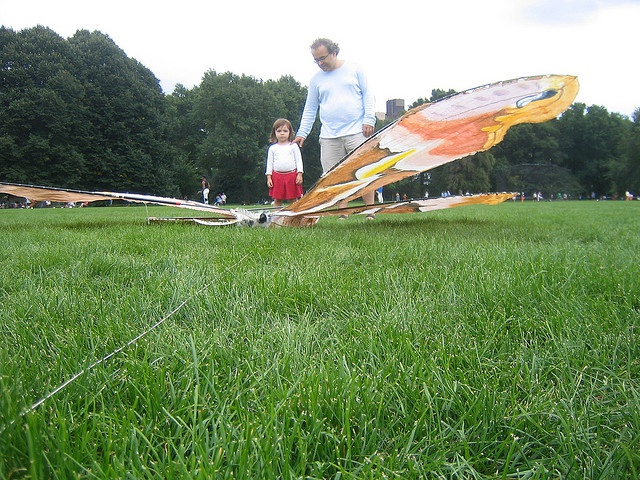Describe the objects in this image and their specific colors. I can see kite in white, lightgray, and tan tones, people in white, lavender, darkgray, and lightblue tones, people in white, brown, and gray tones, people in white, black, gray, and darkgray tones, and people in white, lavender, black, darkgray, and gray tones in this image. 